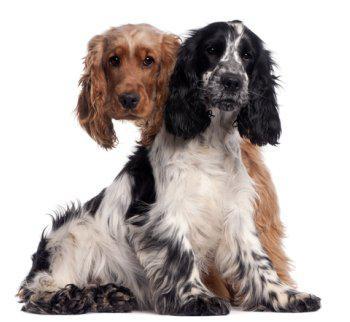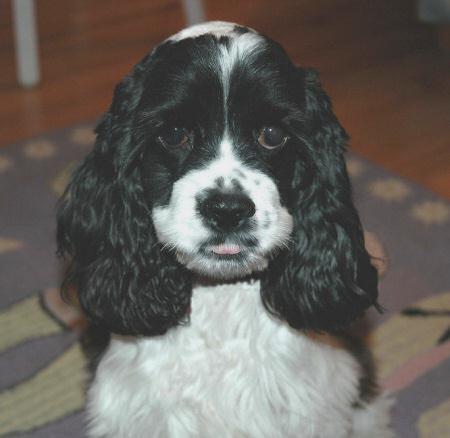The first image is the image on the left, the second image is the image on the right. Evaluate the accuracy of this statement regarding the images: "Two out of the three dogs have some black fur.". Is it true? Answer yes or no. Yes. The first image is the image on the left, the second image is the image on the right. For the images shown, is this caption "One image shows a spaniel with a white muzzle and black fur on eye and ear areas, and the other image shows two different colored spaniels posed close together." true? Answer yes or no. Yes. 